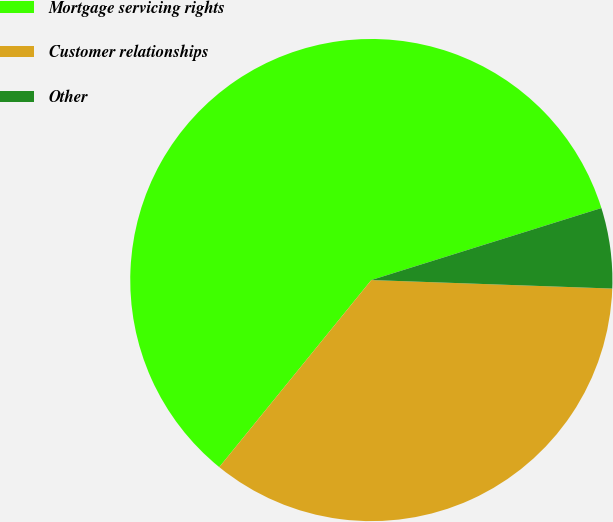<chart> <loc_0><loc_0><loc_500><loc_500><pie_chart><fcel>Mortgage servicing rights<fcel>Customer relationships<fcel>Other<nl><fcel>59.31%<fcel>35.3%<fcel>5.39%<nl></chart> 